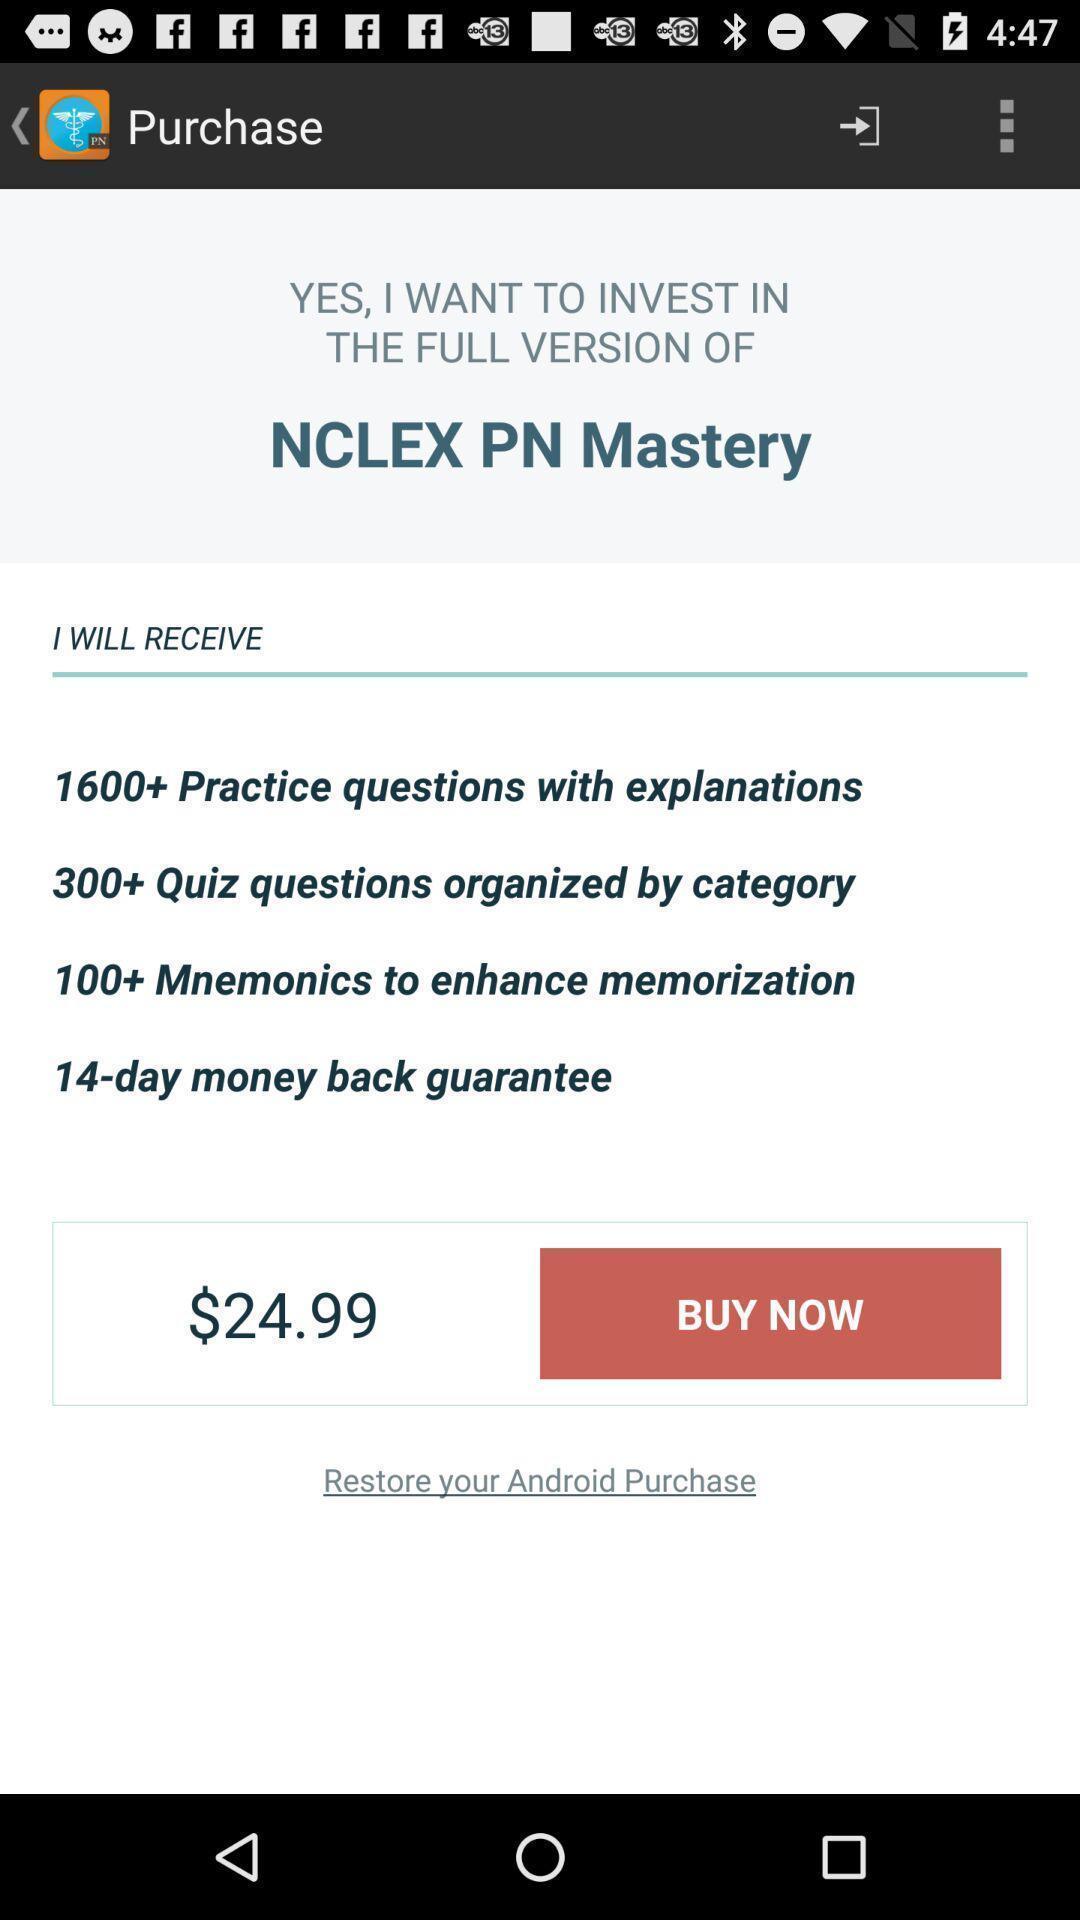Tell me what you see in this picture. Page showing purchase options for a learning based app. 